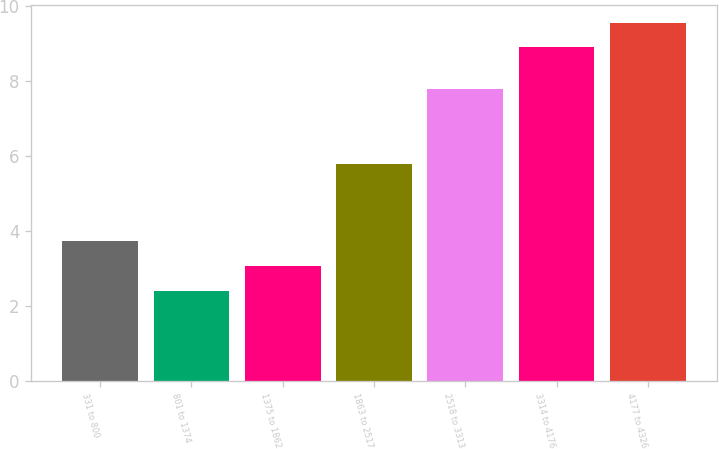<chart> <loc_0><loc_0><loc_500><loc_500><bar_chart><fcel>331 to 800<fcel>801 to 1374<fcel>1375 to 1862<fcel>1863 to 2517<fcel>2518 to 3313<fcel>3314 to 4176<fcel>4177 to 4326<nl><fcel>3.72<fcel>2.4<fcel>3.06<fcel>5.8<fcel>7.8<fcel>8.9<fcel>9.56<nl></chart> 